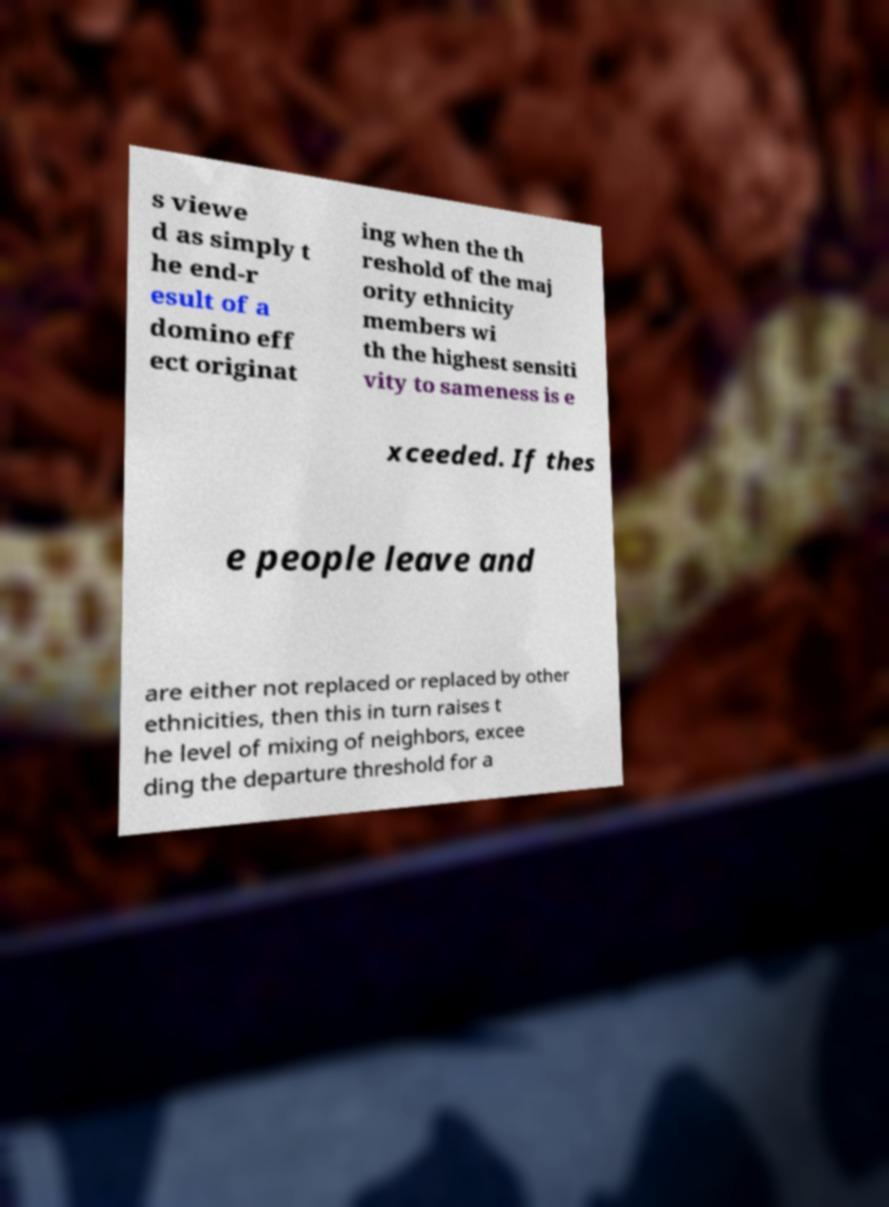What messages or text are displayed in this image? I need them in a readable, typed format. s viewe d as simply t he end-r esult of a domino eff ect originat ing when the th reshold of the maj ority ethnicity members wi th the highest sensiti vity to sameness is e xceeded. If thes e people leave and are either not replaced or replaced by other ethnicities, then this in turn raises t he level of mixing of neighbors, excee ding the departure threshold for a 